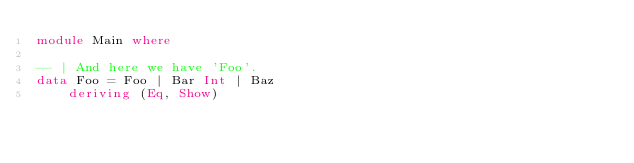<code> <loc_0><loc_0><loc_500><loc_500><_Haskell_>module Main where

-- | And here we have 'Foo'.
data Foo = Foo | Bar Int | Baz
    deriving (Eq, Show)
</code> 